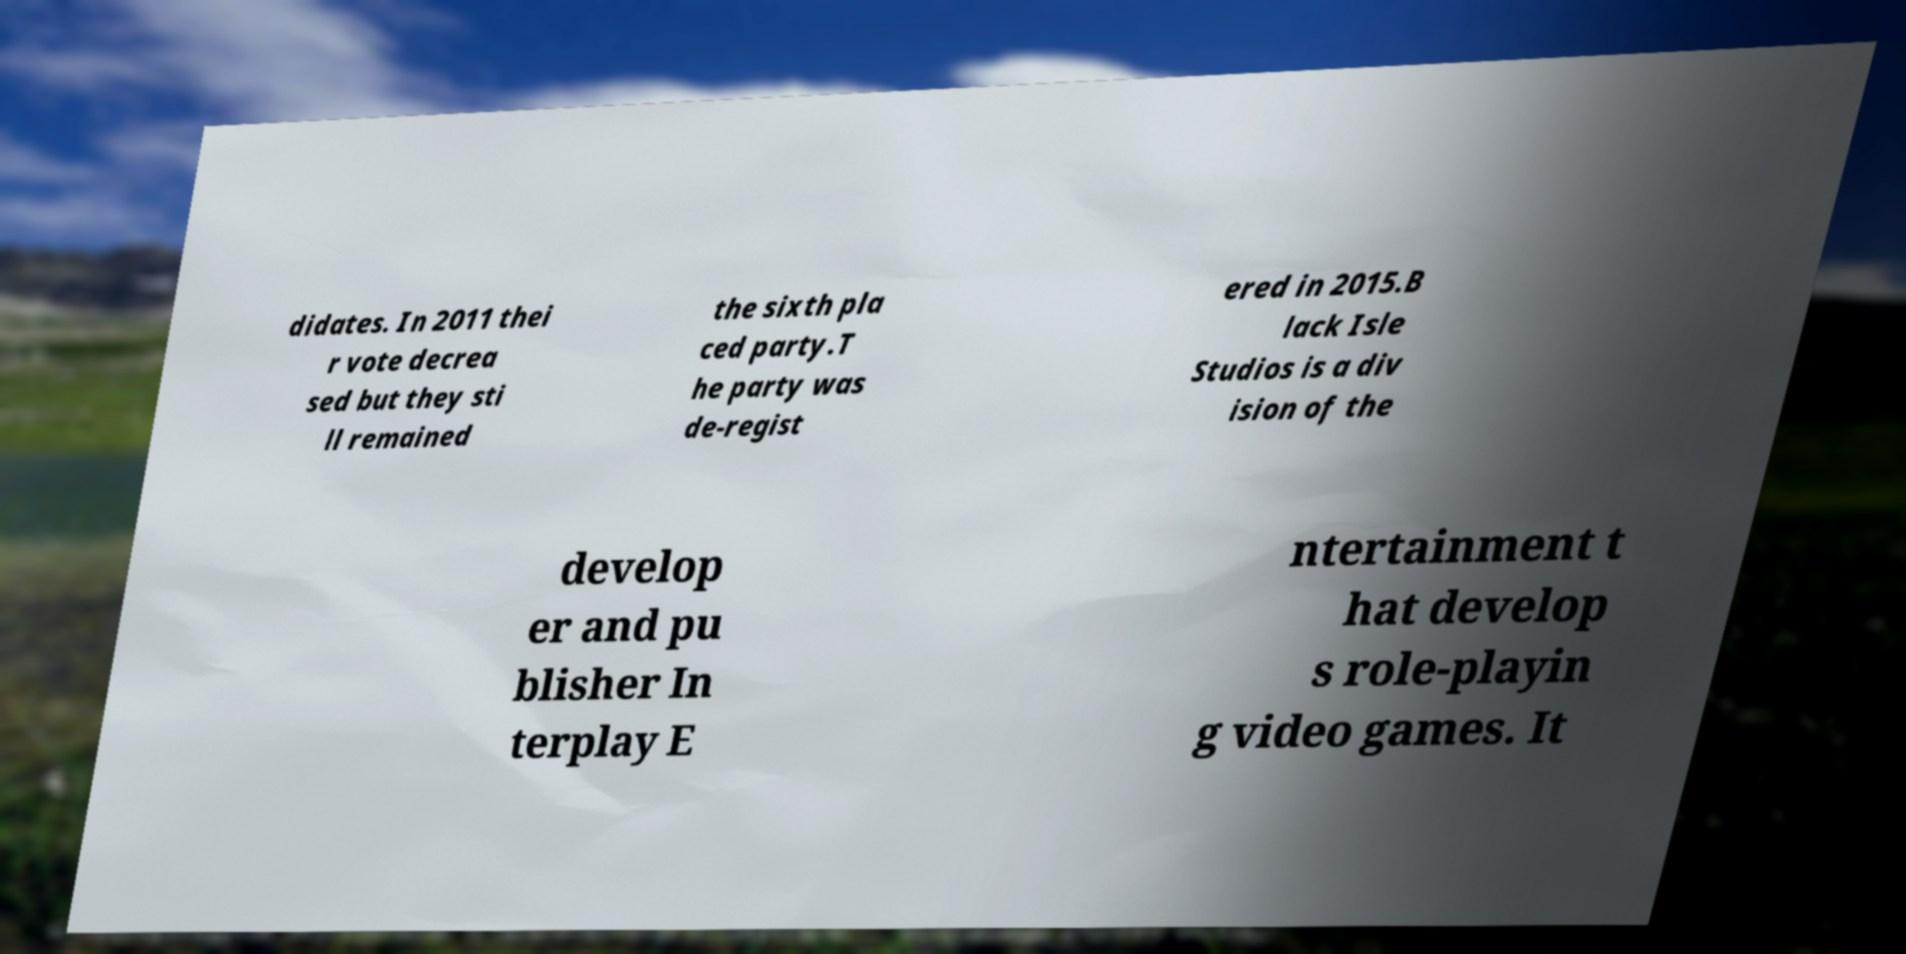For documentation purposes, I need the text within this image transcribed. Could you provide that? didates. In 2011 thei r vote decrea sed but they sti ll remained the sixth pla ced party.T he party was de-regist ered in 2015.B lack Isle Studios is a div ision of the develop er and pu blisher In terplay E ntertainment t hat develop s role-playin g video games. It 